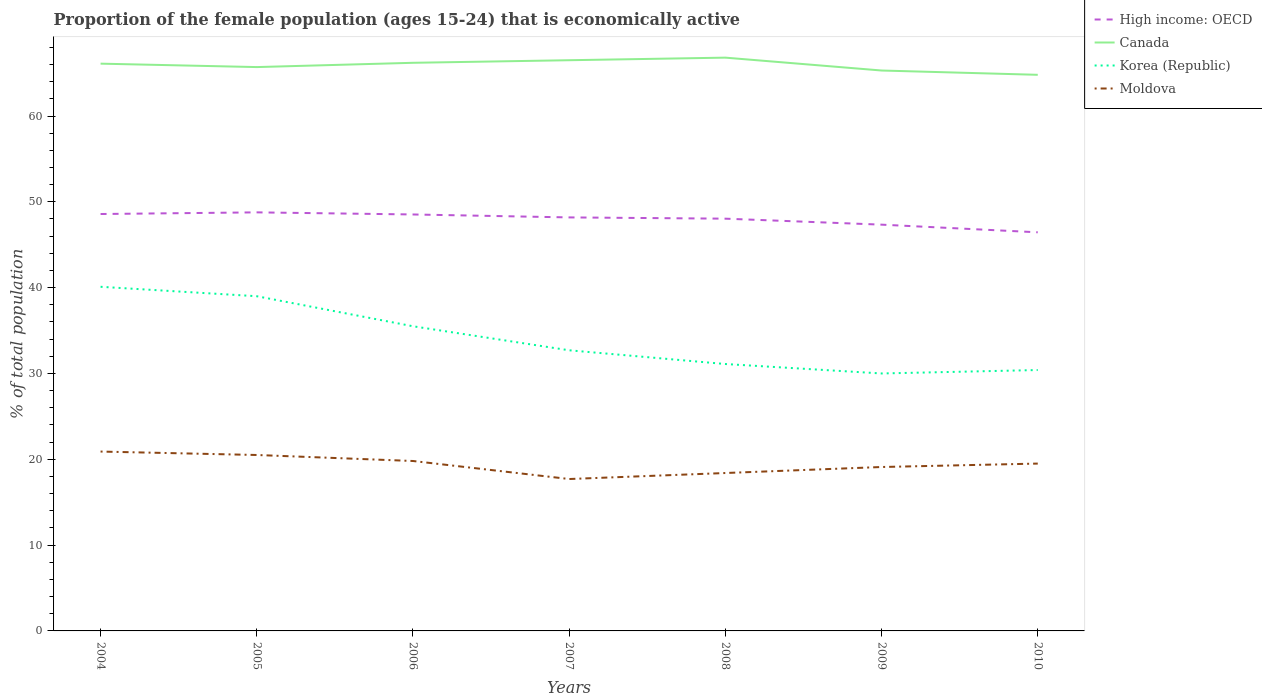How many different coloured lines are there?
Offer a very short reply. 4. Does the line corresponding to Korea (Republic) intersect with the line corresponding to High income: OECD?
Offer a very short reply. No. Is the number of lines equal to the number of legend labels?
Your answer should be very brief. Yes. Across all years, what is the maximum proportion of the female population that is economically active in Canada?
Give a very brief answer. 64.8. What is the total proportion of the female population that is economically active in Korea (Republic) in the graph?
Keep it short and to the point. 8.6. What is the difference between two consecutive major ticks on the Y-axis?
Make the answer very short. 10. Does the graph contain grids?
Give a very brief answer. No. How many legend labels are there?
Give a very brief answer. 4. What is the title of the graph?
Make the answer very short. Proportion of the female population (ages 15-24) that is economically active. What is the label or title of the Y-axis?
Make the answer very short. % of total population. What is the % of total population in High income: OECD in 2004?
Provide a short and direct response. 48.58. What is the % of total population of Canada in 2004?
Your response must be concise. 66.1. What is the % of total population of Korea (Republic) in 2004?
Your answer should be compact. 40.1. What is the % of total population in Moldova in 2004?
Offer a terse response. 20.9. What is the % of total population in High income: OECD in 2005?
Offer a terse response. 48.77. What is the % of total population in Canada in 2005?
Provide a succinct answer. 65.7. What is the % of total population of High income: OECD in 2006?
Give a very brief answer. 48.53. What is the % of total population of Canada in 2006?
Make the answer very short. 66.2. What is the % of total population in Korea (Republic) in 2006?
Make the answer very short. 35.5. What is the % of total population in Moldova in 2006?
Provide a succinct answer. 19.8. What is the % of total population of High income: OECD in 2007?
Your answer should be compact. 48.18. What is the % of total population in Canada in 2007?
Keep it short and to the point. 66.5. What is the % of total population in Korea (Republic) in 2007?
Provide a short and direct response. 32.7. What is the % of total population in Moldova in 2007?
Give a very brief answer. 17.7. What is the % of total population of High income: OECD in 2008?
Offer a very short reply. 48.04. What is the % of total population in Canada in 2008?
Your answer should be very brief. 66.8. What is the % of total population in Korea (Republic) in 2008?
Keep it short and to the point. 31.1. What is the % of total population of Moldova in 2008?
Ensure brevity in your answer.  18.4. What is the % of total population of High income: OECD in 2009?
Ensure brevity in your answer.  47.34. What is the % of total population of Canada in 2009?
Offer a terse response. 65.3. What is the % of total population in Moldova in 2009?
Offer a very short reply. 19.1. What is the % of total population of High income: OECD in 2010?
Ensure brevity in your answer.  46.45. What is the % of total population in Canada in 2010?
Your response must be concise. 64.8. What is the % of total population in Korea (Republic) in 2010?
Give a very brief answer. 30.4. What is the % of total population in Moldova in 2010?
Your answer should be compact. 19.5. Across all years, what is the maximum % of total population in High income: OECD?
Offer a terse response. 48.77. Across all years, what is the maximum % of total population in Canada?
Ensure brevity in your answer.  66.8. Across all years, what is the maximum % of total population of Korea (Republic)?
Give a very brief answer. 40.1. Across all years, what is the maximum % of total population of Moldova?
Give a very brief answer. 20.9. Across all years, what is the minimum % of total population of High income: OECD?
Give a very brief answer. 46.45. Across all years, what is the minimum % of total population of Canada?
Make the answer very short. 64.8. Across all years, what is the minimum % of total population in Korea (Republic)?
Your answer should be compact. 30. Across all years, what is the minimum % of total population in Moldova?
Provide a succinct answer. 17.7. What is the total % of total population of High income: OECD in the graph?
Make the answer very short. 335.89. What is the total % of total population in Canada in the graph?
Offer a very short reply. 461.4. What is the total % of total population of Korea (Republic) in the graph?
Make the answer very short. 238.8. What is the total % of total population in Moldova in the graph?
Offer a terse response. 135.9. What is the difference between the % of total population of High income: OECD in 2004 and that in 2005?
Offer a terse response. -0.19. What is the difference between the % of total population in Canada in 2004 and that in 2005?
Ensure brevity in your answer.  0.4. What is the difference between the % of total population in Korea (Republic) in 2004 and that in 2005?
Keep it short and to the point. 1.1. What is the difference between the % of total population of High income: OECD in 2004 and that in 2006?
Keep it short and to the point. 0.05. What is the difference between the % of total population of Canada in 2004 and that in 2006?
Provide a succinct answer. -0.1. What is the difference between the % of total population in Korea (Republic) in 2004 and that in 2006?
Your response must be concise. 4.6. What is the difference between the % of total population in Moldova in 2004 and that in 2006?
Your answer should be very brief. 1.1. What is the difference between the % of total population of High income: OECD in 2004 and that in 2007?
Your answer should be compact. 0.4. What is the difference between the % of total population of Canada in 2004 and that in 2007?
Your response must be concise. -0.4. What is the difference between the % of total population of Moldova in 2004 and that in 2007?
Make the answer very short. 3.2. What is the difference between the % of total population of High income: OECD in 2004 and that in 2008?
Your response must be concise. 0.54. What is the difference between the % of total population of Canada in 2004 and that in 2008?
Your response must be concise. -0.7. What is the difference between the % of total population in Moldova in 2004 and that in 2008?
Offer a terse response. 2.5. What is the difference between the % of total population of High income: OECD in 2004 and that in 2009?
Your answer should be compact. 1.24. What is the difference between the % of total population of Canada in 2004 and that in 2009?
Make the answer very short. 0.8. What is the difference between the % of total population of Korea (Republic) in 2004 and that in 2009?
Provide a succinct answer. 10.1. What is the difference between the % of total population in High income: OECD in 2004 and that in 2010?
Provide a succinct answer. 2.13. What is the difference between the % of total population of High income: OECD in 2005 and that in 2006?
Ensure brevity in your answer.  0.25. What is the difference between the % of total population in Korea (Republic) in 2005 and that in 2006?
Offer a very short reply. 3.5. What is the difference between the % of total population in Moldova in 2005 and that in 2006?
Provide a succinct answer. 0.7. What is the difference between the % of total population of High income: OECD in 2005 and that in 2007?
Make the answer very short. 0.59. What is the difference between the % of total population of Moldova in 2005 and that in 2007?
Make the answer very short. 2.8. What is the difference between the % of total population in High income: OECD in 2005 and that in 2008?
Your answer should be compact. 0.73. What is the difference between the % of total population of Canada in 2005 and that in 2008?
Provide a succinct answer. -1.1. What is the difference between the % of total population in Moldova in 2005 and that in 2008?
Offer a very short reply. 2.1. What is the difference between the % of total population of High income: OECD in 2005 and that in 2009?
Offer a very short reply. 1.43. What is the difference between the % of total population of Korea (Republic) in 2005 and that in 2009?
Make the answer very short. 9. What is the difference between the % of total population of High income: OECD in 2005 and that in 2010?
Provide a short and direct response. 2.32. What is the difference between the % of total population in Canada in 2005 and that in 2010?
Offer a terse response. 0.9. What is the difference between the % of total population of High income: OECD in 2006 and that in 2007?
Make the answer very short. 0.34. What is the difference between the % of total population in Canada in 2006 and that in 2007?
Your answer should be very brief. -0.3. What is the difference between the % of total population of Korea (Republic) in 2006 and that in 2007?
Provide a succinct answer. 2.8. What is the difference between the % of total population of Moldova in 2006 and that in 2007?
Offer a terse response. 2.1. What is the difference between the % of total population of High income: OECD in 2006 and that in 2008?
Provide a short and direct response. 0.49. What is the difference between the % of total population of Moldova in 2006 and that in 2008?
Make the answer very short. 1.4. What is the difference between the % of total population in High income: OECD in 2006 and that in 2009?
Provide a succinct answer. 1.19. What is the difference between the % of total population in Korea (Republic) in 2006 and that in 2009?
Provide a succinct answer. 5.5. What is the difference between the % of total population in Moldova in 2006 and that in 2009?
Offer a terse response. 0.7. What is the difference between the % of total population of High income: OECD in 2006 and that in 2010?
Offer a terse response. 2.08. What is the difference between the % of total population of Canada in 2006 and that in 2010?
Offer a terse response. 1.4. What is the difference between the % of total population of High income: OECD in 2007 and that in 2008?
Give a very brief answer. 0.15. What is the difference between the % of total population of High income: OECD in 2007 and that in 2009?
Provide a succinct answer. 0.84. What is the difference between the % of total population in Canada in 2007 and that in 2009?
Give a very brief answer. 1.2. What is the difference between the % of total population of Korea (Republic) in 2007 and that in 2009?
Keep it short and to the point. 2.7. What is the difference between the % of total population in Moldova in 2007 and that in 2009?
Provide a short and direct response. -1.4. What is the difference between the % of total population in High income: OECD in 2007 and that in 2010?
Provide a succinct answer. 1.74. What is the difference between the % of total population of Korea (Republic) in 2007 and that in 2010?
Your answer should be compact. 2.3. What is the difference between the % of total population in Moldova in 2007 and that in 2010?
Make the answer very short. -1.8. What is the difference between the % of total population of High income: OECD in 2008 and that in 2009?
Ensure brevity in your answer.  0.7. What is the difference between the % of total population in Canada in 2008 and that in 2009?
Your answer should be very brief. 1.5. What is the difference between the % of total population in Korea (Republic) in 2008 and that in 2009?
Provide a succinct answer. 1.1. What is the difference between the % of total population in High income: OECD in 2008 and that in 2010?
Make the answer very short. 1.59. What is the difference between the % of total population in Canada in 2008 and that in 2010?
Ensure brevity in your answer.  2. What is the difference between the % of total population in Korea (Republic) in 2008 and that in 2010?
Ensure brevity in your answer.  0.7. What is the difference between the % of total population in High income: OECD in 2009 and that in 2010?
Keep it short and to the point. 0.89. What is the difference between the % of total population in Canada in 2009 and that in 2010?
Your answer should be compact. 0.5. What is the difference between the % of total population in Moldova in 2009 and that in 2010?
Ensure brevity in your answer.  -0.4. What is the difference between the % of total population in High income: OECD in 2004 and the % of total population in Canada in 2005?
Provide a succinct answer. -17.12. What is the difference between the % of total population in High income: OECD in 2004 and the % of total population in Korea (Republic) in 2005?
Make the answer very short. 9.58. What is the difference between the % of total population in High income: OECD in 2004 and the % of total population in Moldova in 2005?
Your answer should be compact. 28.08. What is the difference between the % of total population of Canada in 2004 and the % of total population of Korea (Republic) in 2005?
Provide a short and direct response. 27.1. What is the difference between the % of total population in Canada in 2004 and the % of total population in Moldova in 2005?
Make the answer very short. 45.6. What is the difference between the % of total population of Korea (Republic) in 2004 and the % of total population of Moldova in 2005?
Give a very brief answer. 19.6. What is the difference between the % of total population of High income: OECD in 2004 and the % of total population of Canada in 2006?
Your response must be concise. -17.62. What is the difference between the % of total population in High income: OECD in 2004 and the % of total population in Korea (Republic) in 2006?
Your response must be concise. 13.08. What is the difference between the % of total population in High income: OECD in 2004 and the % of total population in Moldova in 2006?
Offer a terse response. 28.78. What is the difference between the % of total population in Canada in 2004 and the % of total population in Korea (Republic) in 2006?
Provide a short and direct response. 30.6. What is the difference between the % of total population of Canada in 2004 and the % of total population of Moldova in 2006?
Your answer should be very brief. 46.3. What is the difference between the % of total population of Korea (Republic) in 2004 and the % of total population of Moldova in 2006?
Provide a short and direct response. 20.3. What is the difference between the % of total population in High income: OECD in 2004 and the % of total population in Canada in 2007?
Keep it short and to the point. -17.92. What is the difference between the % of total population of High income: OECD in 2004 and the % of total population of Korea (Republic) in 2007?
Provide a short and direct response. 15.88. What is the difference between the % of total population of High income: OECD in 2004 and the % of total population of Moldova in 2007?
Your answer should be very brief. 30.88. What is the difference between the % of total population in Canada in 2004 and the % of total population in Korea (Republic) in 2007?
Your answer should be very brief. 33.4. What is the difference between the % of total population in Canada in 2004 and the % of total population in Moldova in 2007?
Ensure brevity in your answer.  48.4. What is the difference between the % of total population of Korea (Republic) in 2004 and the % of total population of Moldova in 2007?
Your answer should be compact. 22.4. What is the difference between the % of total population in High income: OECD in 2004 and the % of total population in Canada in 2008?
Provide a succinct answer. -18.22. What is the difference between the % of total population of High income: OECD in 2004 and the % of total population of Korea (Republic) in 2008?
Offer a terse response. 17.48. What is the difference between the % of total population of High income: OECD in 2004 and the % of total population of Moldova in 2008?
Keep it short and to the point. 30.18. What is the difference between the % of total population of Canada in 2004 and the % of total population of Moldova in 2008?
Make the answer very short. 47.7. What is the difference between the % of total population of Korea (Republic) in 2004 and the % of total population of Moldova in 2008?
Offer a terse response. 21.7. What is the difference between the % of total population in High income: OECD in 2004 and the % of total population in Canada in 2009?
Ensure brevity in your answer.  -16.72. What is the difference between the % of total population of High income: OECD in 2004 and the % of total population of Korea (Republic) in 2009?
Provide a short and direct response. 18.58. What is the difference between the % of total population in High income: OECD in 2004 and the % of total population in Moldova in 2009?
Your answer should be very brief. 29.48. What is the difference between the % of total population in Canada in 2004 and the % of total population in Korea (Republic) in 2009?
Keep it short and to the point. 36.1. What is the difference between the % of total population of Canada in 2004 and the % of total population of Moldova in 2009?
Give a very brief answer. 47. What is the difference between the % of total population in High income: OECD in 2004 and the % of total population in Canada in 2010?
Give a very brief answer. -16.22. What is the difference between the % of total population in High income: OECD in 2004 and the % of total population in Korea (Republic) in 2010?
Your response must be concise. 18.18. What is the difference between the % of total population of High income: OECD in 2004 and the % of total population of Moldova in 2010?
Provide a succinct answer. 29.08. What is the difference between the % of total population in Canada in 2004 and the % of total population in Korea (Republic) in 2010?
Your answer should be very brief. 35.7. What is the difference between the % of total population in Canada in 2004 and the % of total population in Moldova in 2010?
Offer a very short reply. 46.6. What is the difference between the % of total population in Korea (Republic) in 2004 and the % of total population in Moldova in 2010?
Provide a short and direct response. 20.6. What is the difference between the % of total population in High income: OECD in 2005 and the % of total population in Canada in 2006?
Your response must be concise. -17.43. What is the difference between the % of total population of High income: OECD in 2005 and the % of total population of Korea (Republic) in 2006?
Provide a succinct answer. 13.27. What is the difference between the % of total population of High income: OECD in 2005 and the % of total population of Moldova in 2006?
Make the answer very short. 28.97. What is the difference between the % of total population of Canada in 2005 and the % of total population of Korea (Republic) in 2006?
Your answer should be very brief. 30.2. What is the difference between the % of total population of Canada in 2005 and the % of total population of Moldova in 2006?
Provide a short and direct response. 45.9. What is the difference between the % of total population of High income: OECD in 2005 and the % of total population of Canada in 2007?
Your answer should be compact. -17.73. What is the difference between the % of total population in High income: OECD in 2005 and the % of total population in Korea (Republic) in 2007?
Provide a succinct answer. 16.07. What is the difference between the % of total population of High income: OECD in 2005 and the % of total population of Moldova in 2007?
Offer a terse response. 31.07. What is the difference between the % of total population in Canada in 2005 and the % of total population in Korea (Republic) in 2007?
Offer a terse response. 33. What is the difference between the % of total population in Korea (Republic) in 2005 and the % of total population in Moldova in 2007?
Provide a short and direct response. 21.3. What is the difference between the % of total population of High income: OECD in 2005 and the % of total population of Canada in 2008?
Your response must be concise. -18.03. What is the difference between the % of total population of High income: OECD in 2005 and the % of total population of Korea (Republic) in 2008?
Your answer should be very brief. 17.67. What is the difference between the % of total population in High income: OECD in 2005 and the % of total population in Moldova in 2008?
Offer a very short reply. 30.37. What is the difference between the % of total population in Canada in 2005 and the % of total population in Korea (Republic) in 2008?
Your answer should be compact. 34.6. What is the difference between the % of total population in Canada in 2005 and the % of total population in Moldova in 2008?
Make the answer very short. 47.3. What is the difference between the % of total population in Korea (Republic) in 2005 and the % of total population in Moldova in 2008?
Ensure brevity in your answer.  20.6. What is the difference between the % of total population in High income: OECD in 2005 and the % of total population in Canada in 2009?
Provide a succinct answer. -16.53. What is the difference between the % of total population of High income: OECD in 2005 and the % of total population of Korea (Republic) in 2009?
Provide a succinct answer. 18.77. What is the difference between the % of total population of High income: OECD in 2005 and the % of total population of Moldova in 2009?
Your answer should be compact. 29.67. What is the difference between the % of total population of Canada in 2005 and the % of total population of Korea (Republic) in 2009?
Offer a very short reply. 35.7. What is the difference between the % of total population of Canada in 2005 and the % of total population of Moldova in 2009?
Provide a short and direct response. 46.6. What is the difference between the % of total population of Korea (Republic) in 2005 and the % of total population of Moldova in 2009?
Give a very brief answer. 19.9. What is the difference between the % of total population of High income: OECD in 2005 and the % of total population of Canada in 2010?
Give a very brief answer. -16.03. What is the difference between the % of total population in High income: OECD in 2005 and the % of total population in Korea (Republic) in 2010?
Make the answer very short. 18.37. What is the difference between the % of total population of High income: OECD in 2005 and the % of total population of Moldova in 2010?
Offer a terse response. 29.27. What is the difference between the % of total population in Canada in 2005 and the % of total population in Korea (Republic) in 2010?
Keep it short and to the point. 35.3. What is the difference between the % of total population of Canada in 2005 and the % of total population of Moldova in 2010?
Provide a succinct answer. 46.2. What is the difference between the % of total population in High income: OECD in 2006 and the % of total population in Canada in 2007?
Keep it short and to the point. -17.97. What is the difference between the % of total population of High income: OECD in 2006 and the % of total population of Korea (Republic) in 2007?
Keep it short and to the point. 15.83. What is the difference between the % of total population of High income: OECD in 2006 and the % of total population of Moldova in 2007?
Offer a very short reply. 30.83. What is the difference between the % of total population in Canada in 2006 and the % of total population in Korea (Republic) in 2007?
Provide a short and direct response. 33.5. What is the difference between the % of total population of Canada in 2006 and the % of total population of Moldova in 2007?
Give a very brief answer. 48.5. What is the difference between the % of total population of Korea (Republic) in 2006 and the % of total population of Moldova in 2007?
Give a very brief answer. 17.8. What is the difference between the % of total population of High income: OECD in 2006 and the % of total population of Canada in 2008?
Make the answer very short. -18.27. What is the difference between the % of total population in High income: OECD in 2006 and the % of total population in Korea (Republic) in 2008?
Offer a terse response. 17.43. What is the difference between the % of total population in High income: OECD in 2006 and the % of total population in Moldova in 2008?
Ensure brevity in your answer.  30.13. What is the difference between the % of total population in Canada in 2006 and the % of total population in Korea (Republic) in 2008?
Keep it short and to the point. 35.1. What is the difference between the % of total population in Canada in 2006 and the % of total population in Moldova in 2008?
Your answer should be very brief. 47.8. What is the difference between the % of total population in Korea (Republic) in 2006 and the % of total population in Moldova in 2008?
Offer a very short reply. 17.1. What is the difference between the % of total population of High income: OECD in 2006 and the % of total population of Canada in 2009?
Give a very brief answer. -16.77. What is the difference between the % of total population in High income: OECD in 2006 and the % of total population in Korea (Republic) in 2009?
Your response must be concise. 18.53. What is the difference between the % of total population of High income: OECD in 2006 and the % of total population of Moldova in 2009?
Provide a short and direct response. 29.43. What is the difference between the % of total population of Canada in 2006 and the % of total population of Korea (Republic) in 2009?
Your answer should be very brief. 36.2. What is the difference between the % of total population of Canada in 2006 and the % of total population of Moldova in 2009?
Your response must be concise. 47.1. What is the difference between the % of total population of Korea (Republic) in 2006 and the % of total population of Moldova in 2009?
Offer a very short reply. 16.4. What is the difference between the % of total population in High income: OECD in 2006 and the % of total population in Canada in 2010?
Provide a succinct answer. -16.27. What is the difference between the % of total population in High income: OECD in 2006 and the % of total population in Korea (Republic) in 2010?
Make the answer very short. 18.13. What is the difference between the % of total population of High income: OECD in 2006 and the % of total population of Moldova in 2010?
Your answer should be very brief. 29.03. What is the difference between the % of total population in Canada in 2006 and the % of total population in Korea (Republic) in 2010?
Offer a very short reply. 35.8. What is the difference between the % of total population of Canada in 2006 and the % of total population of Moldova in 2010?
Provide a short and direct response. 46.7. What is the difference between the % of total population of High income: OECD in 2007 and the % of total population of Canada in 2008?
Give a very brief answer. -18.62. What is the difference between the % of total population in High income: OECD in 2007 and the % of total population in Korea (Republic) in 2008?
Offer a terse response. 17.08. What is the difference between the % of total population in High income: OECD in 2007 and the % of total population in Moldova in 2008?
Your answer should be very brief. 29.78. What is the difference between the % of total population in Canada in 2007 and the % of total population in Korea (Republic) in 2008?
Your answer should be very brief. 35.4. What is the difference between the % of total population of Canada in 2007 and the % of total population of Moldova in 2008?
Offer a terse response. 48.1. What is the difference between the % of total population in Korea (Republic) in 2007 and the % of total population in Moldova in 2008?
Keep it short and to the point. 14.3. What is the difference between the % of total population in High income: OECD in 2007 and the % of total population in Canada in 2009?
Give a very brief answer. -17.12. What is the difference between the % of total population in High income: OECD in 2007 and the % of total population in Korea (Republic) in 2009?
Make the answer very short. 18.18. What is the difference between the % of total population of High income: OECD in 2007 and the % of total population of Moldova in 2009?
Make the answer very short. 29.08. What is the difference between the % of total population in Canada in 2007 and the % of total population in Korea (Republic) in 2009?
Ensure brevity in your answer.  36.5. What is the difference between the % of total population of Canada in 2007 and the % of total population of Moldova in 2009?
Give a very brief answer. 47.4. What is the difference between the % of total population of Korea (Republic) in 2007 and the % of total population of Moldova in 2009?
Your response must be concise. 13.6. What is the difference between the % of total population in High income: OECD in 2007 and the % of total population in Canada in 2010?
Keep it short and to the point. -16.62. What is the difference between the % of total population in High income: OECD in 2007 and the % of total population in Korea (Republic) in 2010?
Your answer should be compact. 17.78. What is the difference between the % of total population in High income: OECD in 2007 and the % of total population in Moldova in 2010?
Your answer should be very brief. 28.68. What is the difference between the % of total population in Canada in 2007 and the % of total population in Korea (Republic) in 2010?
Offer a very short reply. 36.1. What is the difference between the % of total population in High income: OECD in 2008 and the % of total population in Canada in 2009?
Ensure brevity in your answer.  -17.26. What is the difference between the % of total population of High income: OECD in 2008 and the % of total population of Korea (Republic) in 2009?
Provide a succinct answer. 18.04. What is the difference between the % of total population of High income: OECD in 2008 and the % of total population of Moldova in 2009?
Ensure brevity in your answer.  28.94. What is the difference between the % of total population in Canada in 2008 and the % of total population in Korea (Republic) in 2009?
Your response must be concise. 36.8. What is the difference between the % of total population in Canada in 2008 and the % of total population in Moldova in 2009?
Provide a short and direct response. 47.7. What is the difference between the % of total population in High income: OECD in 2008 and the % of total population in Canada in 2010?
Provide a succinct answer. -16.76. What is the difference between the % of total population in High income: OECD in 2008 and the % of total population in Korea (Republic) in 2010?
Your answer should be very brief. 17.64. What is the difference between the % of total population in High income: OECD in 2008 and the % of total population in Moldova in 2010?
Provide a short and direct response. 28.54. What is the difference between the % of total population of Canada in 2008 and the % of total population of Korea (Republic) in 2010?
Provide a succinct answer. 36.4. What is the difference between the % of total population in Canada in 2008 and the % of total population in Moldova in 2010?
Your answer should be very brief. 47.3. What is the difference between the % of total population in Korea (Republic) in 2008 and the % of total population in Moldova in 2010?
Offer a terse response. 11.6. What is the difference between the % of total population of High income: OECD in 2009 and the % of total population of Canada in 2010?
Provide a succinct answer. -17.46. What is the difference between the % of total population of High income: OECD in 2009 and the % of total population of Korea (Republic) in 2010?
Give a very brief answer. 16.94. What is the difference between the % of total population in High income: OECD in 2009 and the % of total population in Moldova in 2010?
Provide a succinct answer. 27.84. What is the difference between the % of total population in Canada in 2009 and the % of total population in Korea (Republic) in 2010?
Provide a succinct answer. 34.9. What is the difference between the % of total population of Canada in 2009 and the % of total population of Moldova in 2010?
Offer a very short reply. 45.8. What is the difference between the % of total population of Korea (Republic) in 2009 and the % of total population of Moldova in 2010?
Your answer should be compact. 10.5. What is the average % of total population of High income: OECD per year?
Make the answer very short. 47.98. What is the average % of total population in Canada per year?
Keep it short and to the point. 65.91. What is the average % of total population in Korea (Republic) per year?
Offer a very short reply. 34.11. What is the average % of total population of Moldova per year?
Make the answer very short. 19.41. In the year 2004, what is the difference between the % of total population in High income: OECD and % of total population in Canada?
Offer a very short reply. -17.52. In the year 2004, what is the difference between the % of total population in High income: OECD and % of total population in Korea (Republic)?
Your answer should be very brief. 8.48. In the year 2004, what is the difference between the % of total population of High income: OECD and % of total population of Moldova?
Your answer should be compact. 27.68. In the year 2004, what is the difference between the % of total population in Canada and % of total population in Moldova?
Provide a succinct answer. 45.2. In the year 2004, what is the difference between the % of total population of Korea (Republic) and % of total population of Moldova?
Offer a very short reply. 19.2. In the year 2005, what is the difference between the % of total population of High income: OECD and % of total population of Canada?
Your answer should be compact. -16.93. In the year 2005, what is the difference between the % of total population of High income: OECD and % of total population of Korea (Republic)?
Offer a very short reply. 9.77. In the year 2005, what is the difference between the % of total population in High income: OECD and % of total population in Moldova?
Offer a terse response. 28.27. In the year 2005, what is the difference between the % of total population in Canada and % of total population in Korea (Republic)?
Provide a succinct answer. 26.7. In the year 2005, what is the difference between the % of total population of Canada and % of total population of Moldova?
Keep it short and to the point. 45.2. In the year 2005, what is the difference between the % of total population in Korea (Republic) and % of total population in Moldova?
Provide a short and direct response. 18.5. In the year 2006, what is the difference between the % of total population of High income: OECD and % of total population of Canada?
Provide a short and direct response. -17.67. In the year 2006, what is the difference between the % of total population of High income: OECD and % of total population of Korea (Republic)?
Make the answer very short. 13.03. In the year 2006, what is the difference between the % of total population in High income: OECD and % of total population in Moldova?
Make the answer very short. 28.73. In the year 2006, what is the difference between the % of total population of Canada and % of total population of Korea (Republic)?
Provide a succinct answer. 30.7. In the year 2006, what is the difference between the % of total population in Canada and % of total population in Moldova?
Provide a succinct answer. 46.4. In the year 2006, what is the difference between the % of total population in Korea (Republic) and % of total population in Moldova?
Ensure brevity in your answer.  15.7. In the year 2007, what is the difference between the % of total population in High income: OECD and % of total population in Canada?
Your response must be concise. -18.32. In the year 2007, what is the difference between the % of total population of High income: OECD and % of total population of Korea (Republic)?
Offer a very short reply. 15.48. In the year 2007, what is the difference between the % of total population of High income: OECD and % of total population of Moldova?
Offer a very short reply. 30.48. In the year 2007, what is the difference between the % of total population of Canada and % of total population of Korea (Republic)?
Provide a succinct answer. 33.8. In the year 2007, what is the difference between the % of total population in Canada and % of total population in Moldova?
Give a very brief answer. 48.8. In the year 2007, what is the difference between the % of total population in Korea (Republic) and % of total population in Moldova?
Your answer should be very brief. 15. In the year 2008, what is the difference between the % of total population in High income: OECD and % of total population in Canada?
Offer a terse response. -18.76. In the year 2008, what is the difference between the % of total population of High income: OECD and % of total population of Korea (Republic)?
Your response must be concise. 16.94. In the year 2008, what is the difference between the % of total population of High income: OECD and % of total population of Moldova?
Offer a terse response. 29.64. In the year 2008, what is the difference between the % of total population of Canada and % of total population of Korea (Republic)?
Make the answer very short. 35.7. In the year 2008, what is the difference between the % of total population of Canada and % of total population of Moldova?
Ensure brevity in your answer.  48.4. In the year 2009, what is the difference between the % of total population of High income: OECD and % of total population of Canada?
Your answer should be compact. -17.96. In the year 2009, what is the difference between the % of total population in High income: OECD and % of total population in Korea (Republic)?
Your answer should be compact. 17.34. In the year 2009, what is the difference between the % of total population of High income: OECD and % of total population of Moldova?
Keep it short and to the point. 28.24. In the year 2009, what is the difference between the % of total population in Canada and % of total population in Korea (Republic)?
Keep it short and to the point. 35.3. In the year 2009, what is the difference between the % of total population in Canada and % of total population in Moldova?
Your answer should be very brief. 46.2. In the year 2010, what is the difference between the % of total population of High income: OECD and % of total population of Canada?
Give a very brief answer. -18.35. In the year 2010, what is the difference between the % of total population of High income: OECD and % of total population of Korea (Republic)?
Your answer should be very brief. 16.05. In the year 2010, what is the difference between the % of total population in High income: OECD and % of total population in Moldova?
Offer a very short reply. 26.95. In the year 2010, what is the difference between the % of total population of Canada and % of total population of Korea (Republic)?
Offer a terse response. 34.4. In the year 2010, what is the difference between the % of total population of Canada and % of total population of Moldova?
Make the answer very short. 45.3. What is the ratio of the % of total population of Korea (Republic) in 2004 to that in 2005?
Your response must be concise. 1.03. What is the ratio of the % of total population of Moldova in 2004 to that in 2005?
Offer a terse response. 1.02. What is the ratio of the % of total population in Korea (Republic) in 2004 to that in 2006?
Offer a terse response. 1.13. What is the ratio of the % of total population in Moldova in 2004 to that in 2006?
Your answer should be compact. 1.06. What is the ratio of the % of total population in High income: OECD in 2004 to that in 2007?
Keep it short and to the point. 1.01. What is the ratio of the % of total population of Korea (Republic) in 2004 to that in 2007?
Keep it short and to the point. 1.23. What is the ratio of the % of total population of Moldova in 2004 to that in 2007?
Make the answer very short. 1.18. What is the ratio of the % of total population in High income: OECD in 2004 to that in 2008?
Give a very brief answer. 1.01. What is the ratio of the % of total population of Korea (Republic) in 2004 to that in 2008?
Your answer should be very brief. 1.29. What is the ratio of the % of total population of Moldova in 2004 to that in 2008?
Offer a very short reply. 1.14. What is the ratio of the % of total population of High income: OECD in 2004 to that in 2009?
Give a very brief answer. 1.03. What is the ratio of the % of total population in Canada in 2004 to that in 2009?
Keep it short and to the point. 1.01. What is the ratio of the % of total population of Korea (Republic) in 2004 to that in 2009?
Make the answer very short. 1.34. What is the ratio of the % of total population of Moldova in 2004 to that in 2009?
Your answer should be compact. 1.09. What is the ratio of the % of total population in High income: OECD in 2004 to that in 2010?
Provide a succinct answer. 1.05. What is the ratio of the % of total population of Canada in 2004 to that in 2010?
Your answer should be very brief. 1.02. What is the ratio of the % of total population of Korea (Republic) in 2004 to that in 2010?
Provide a short and direct response. 1.32. What is the ratio of the % of total population in Moldova in 2004 to that in 2010?
Provide a short and direct response. 1.07. What is the ratio of the % of total population in Korea (Republic) in 2005 to that in 2006?
Offer a terse response. 1.1. What is the ratio of the % of total population in Moldova in 2005 to that in 2006?
Provide a short and direct response. 1.04. What is the ratio of the % of total population in High income: OECD in 2005 to that in 2007?
Your response must be concise. 1.01. What is the ratio of the % of total population in Korea (Republic) in 2005 to that in 2007?
Offer a very short reply. 1.19. What is the ratio of the % of total population of Moldova in 2005 to that in 2007?
Offer a terse response. 1.16. What is the ratio of the % of total population in High income: OECD in 2005 to that in 2008?
Your answer should be very brief. 1.02. What is the ratio of the % of total population in Canada in 2005 to that in 2008?
Provide a short and direct response. 0.98. What is the ratio of the % of total population of Korea (Republic) in 2005 to that in 2008?
Offer a very short reply. 1.25. What is the ratio of the % of total population in Moldova in 2005 to that in 2008?
Your response must be concise. 1.11. What is the ratio of the % of total population of High income: OECD in 2005 to that in 2009?
Your response must be concise. 1.03. What is the ratio of the % of total population in Korea (Republic) in 2005 to that in 2009?
Give a very brief answer. 1.3. What is the ratio of the % of total population of Moldova in 2005 to that in 2009?
Provide a succinct answer. 1.07. What is the ratio of the % of total population of Canada in 2005 to that in 2010?
Ensure brevity in your answer.  1.01. What is the ratio of the % of total population in Korea (Republic) in 2005 to that in 2010?
Provide a succinct answer. 1.28. What is the ratio of the % of total population in Moldova in 2005 to that in 2010?
Offer a terse response. 1.05. What is the ratio of the % of total population of High income: OECD in 2006 to that in 2007?
Make the answer very short. 1.01. What is the ratio of the % of total population in Korea (Republic) in 2006 to that in 2007?
Offer a very short reply. 1.09. What is the ratio of the % of total population of Moldova in 2006 to that in 2007?
Provide a succinct answer. 1.12. What is the ratio of the % of total population of High income: OECD in 2006 to that in 2008?
Your answer should be very brief. 1.01. What is the ratio of the % of total population in Canada in 2006 to that in 2008?
Make the answer very short. 0.99. What is the ratio of the % of total population in Korea (Republic) in 2006 to that in 2008?
Make the answer very short. 1.14. What is the ratio of the % of total population of Moldova in 2006 to that in 2008?
Offer a terse response. 1.08. What is the ratio of the % of total population in High income: OECD in 2006 to that in 2009?
Make the answer very short. 1.03. What is the ratio of the % of total population in Canada in 2006 to that in 2009?
Ensure brevity in your answer.  1.01. What is the ratio of the % of total population of Korea (Republic) in 2006 to that in 2009?
Ensure brevity in your answer.  1.18. What is the ratio of the % of total population of Moldova in 2006 to that in 2009?
Give a very brief answer. 1.04. What is the ratio of the % of total population of High income: OECD in 2006 to that in 2010?
Your response must be concise. 1.04. What is the ratio of the % of total population in Canada in 2006 to that in 2010?
Provide a short and direct response. 1.02. What is the ratio of the % of total population of Korea (Republic) in 2006 to that in 2010?
Give a very brief answer. 1.17. What is the ratio of the % of total population of Moldova in 2006 to that in 2010?
Offer a very short reply. 1.02. What is the ratio of the % of total population of High income: OECD in 2007 to that in 2008?
Provide a succinct answer. 1. What is the ratio of the % of total population in Korea (Republic) in 2007 to that in 2008?
Ensure brevity in your answer.  1.05. What is the ratio of the % of total population in High income: OECD in 2007 to that in 2009?
Provide a succinct answer. 1.02. What is the ratio of the % of total population in Canada in 2007 to that in 2009?
Make the answer very short. 1.02. What is the ratio of the % of total population in Korea (Republic) in 2007 to that in 2009?
Offer a very short reply. 1.09. What is the ratio of the % of total population in Moldova in 2007 to that in 2009?
Make the answer very short. 0.93. What is the ratio of the % of total population of High income: OECD in 2007 to that in 2010?
Your answer should be very brief. 1.04. What is the ratio of the % of total population of Canada in 2007 to that in 2010?
Provide a succinct answer. 1.03. What is the ratio of the % of total population in Korea (Republic) in 2007 to that in 2010?
Your response must be concise. 1.08. What is the ratio of the % of total population of Moldova in 2007 to that in 2010?
Offer a terse response. 0.91. What is the ratio of the % of total population of High income: OECD in 2008 to that in 2009?
Provide a short and direct response. 1.01. What is the ratio of the % of total population of Korea (Republic) in 2008 to that in 2009?
Provide a succinct answer. 1.04. What is the ratio of the % of total population of Moldova in 2008 to that in 2009?
Keep it short and to the point. 0.96. What is the ratio of the % of total population in High income: OECD in 2008 to that in 2010?
Offer a very short reply. 1.03. What is the ratio of the % of total population of Canada in 2008 to that in 2010?
Offer a terse response. 1.03. What is the ratio of the % of total population of Korea (Republic) in 2008 to that in 2010?
Ensure brevity in your answer.  1.02. What is the ratio of the % of total population in Moldova in 2008 to that in 2010?
Keep it short and to the point. 0.94. What is the ratio of the % of total population of High income: OECD in 2009 to that in 2010?
Keep it short and to the point. 1.02. What is the ratio of the % of total population of Canada in 2009 to that in 2010?
Offer a terse response. 1.01. What is the ratio of the % of total population of Korea (Republic) in 2009 to that in 2010?
Make the answer very short. 0.99. What is the ratio of the % of total population of Moldova in 2009 to that in 2010?
Your response must be concise. 0.98. What is the difference between the highest and the second highest % of total population in High income: OECD?
Your answer should be compact. 0.19. What is the difference between the highest and the lowest % of total population of High income: OECD?
Offer a very short reply. 2.32. What is the difference between the highest and the lowest % of total population in Canada?
Provide a succinct answer. 2. What is the difference between the highest and the lowest % of total population in Korea (Republic)?
Offer a terse response. 10.1. What is the difference between the highest and the lowest % of total population in Moldova?
Ensure brevity in your answer.  3.2. 